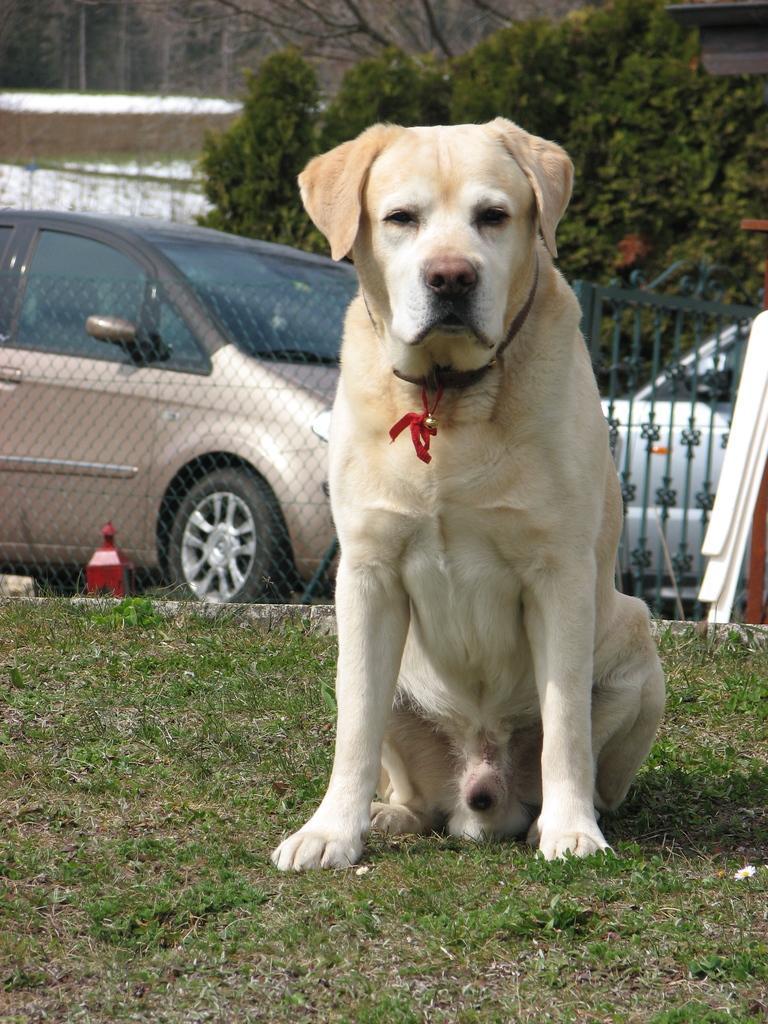Please provide a concise description of this image. In this image we can a dog is sitting on a grassy land, behind fencing, car and tree is present. 